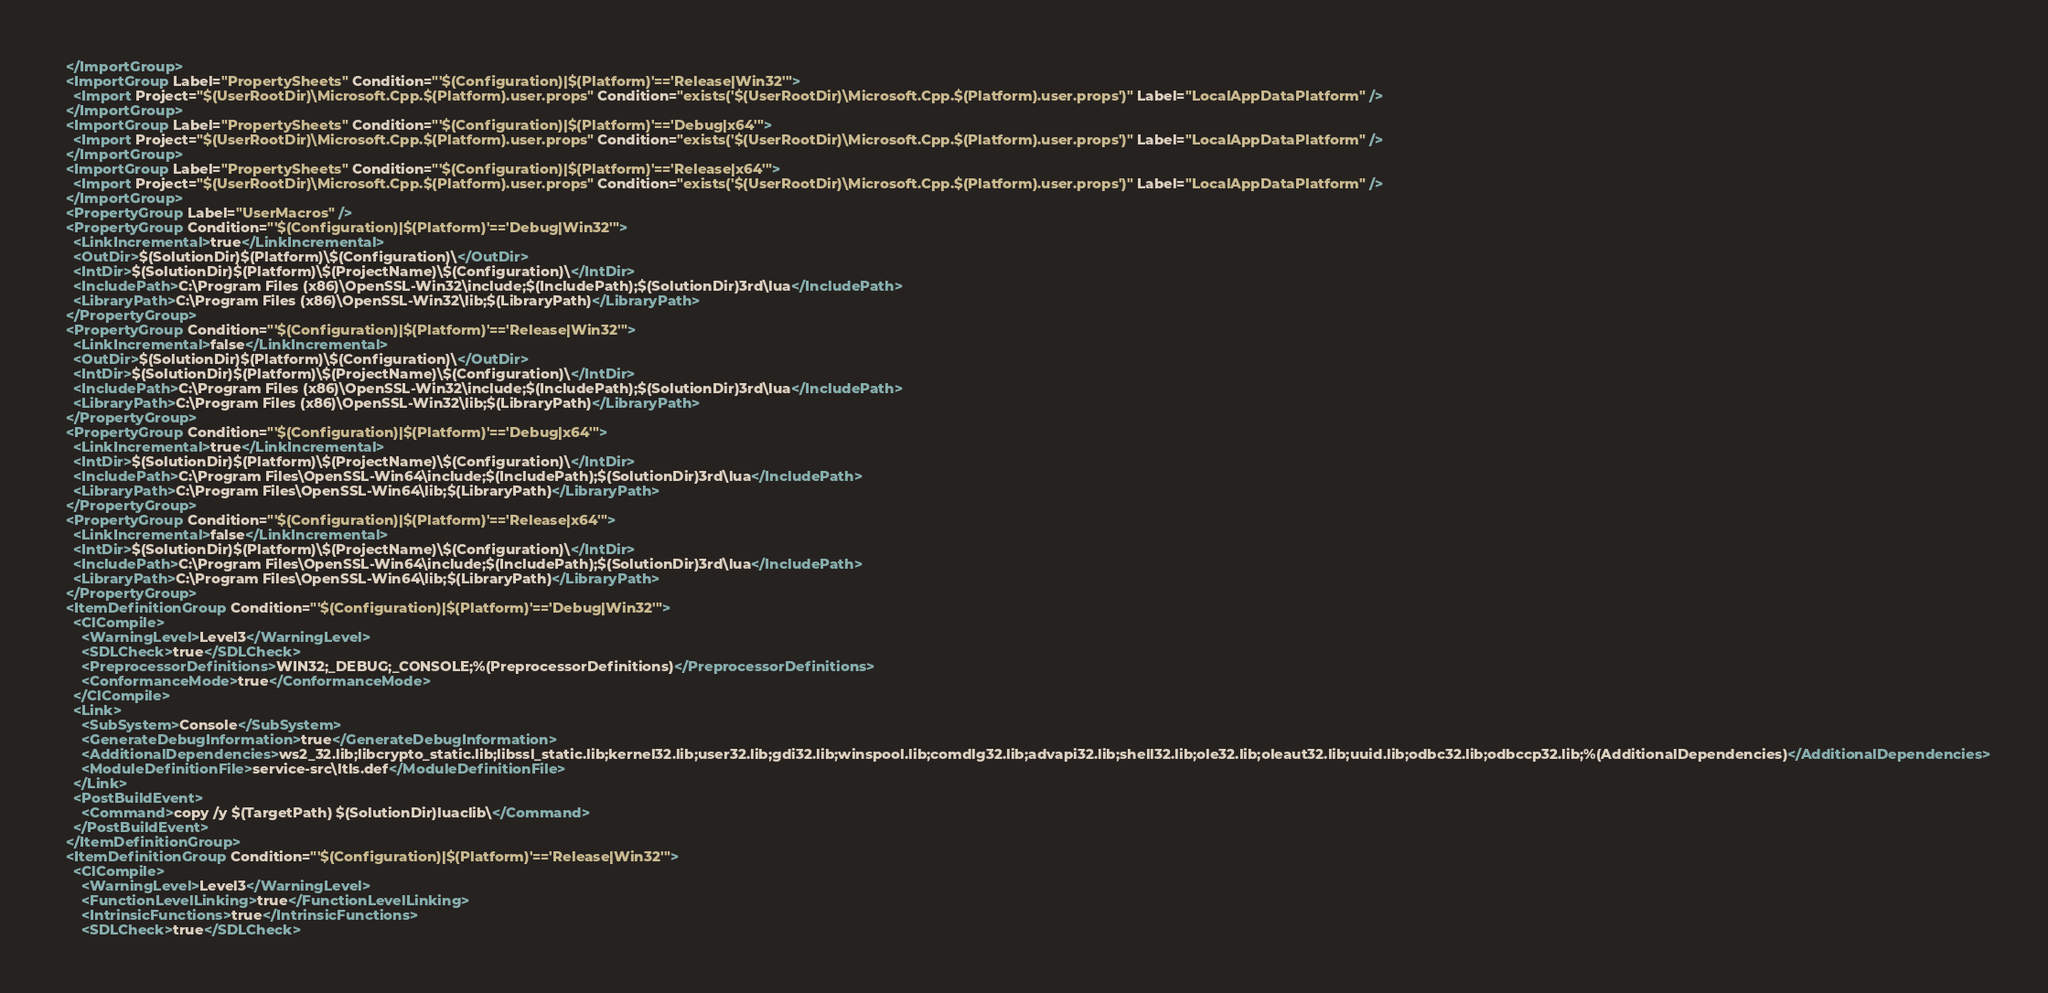Convert code to text. <code><loc_0><loc_0><loc_500><loc_500><_XML_>  </ImportGroup>
  <ImportGroup Label="PropertySheets" Condition="'$(Configuration)|$(Platform)'=='Release|Win32'">
    <Import Project="$(UserRootDir)\Microsoft.Cpp.$(Platform).user.props" Condition="exists('$(UserRootDir)\Microsoft.Cpp.$(Platform).user.props')" Label="LocalAppDataPlatform" />
  </ImportGroup>
  <ImportGroup Label="PropertySheets" Condition="'$(Configuration)|$(Platform)'=='Debug|x64'">
    <Import Project="$(UserRootDir)\Microsoft.Cpp.$(Platform).user.props" Condition="exists('$(UserRootDir)\Microsoft.Cpp.$(Platform).user.props')" Label="LocalAppDataPlatform" />
  </ImportGroup>
  <ImportGroup Label="PropertySheets" Condition="'$(Configuration)|$(Platform)'=='Release|x64'">
    <Import Project="$(UserRootDir)\Microsoft.Cpp.$(Platform).user.props" Condition="exists('$(UserRootDir)\Microsoft.Cpp.$(Platform).user.props')" Label="LocalAppDataPlatform" />
  </ImportGroup>
  <PropertyGroup Label="UserMacros" />
  <PropertyGroup Condition="'$(Configuration)|$(Platform)'=='Debug|Win32'">
    <LinkIncremental>true</LinkIncremental>
    <OutDir>$(SolutionDir)$(Platform)\$(Configuration)\</OutDir>
    <IntDir>$(SolutionDir)$(Platform)\$(ProjectName)\$(Configuration)\</IntDir>
    <IncludePath>C:\Program Files (x86)\OpenSSL-Win32\include;$(IncludePath);$(SolutionDir)3rd\lua</IncludePath>
    <LibraryPath>C:\Program Files (x86)\OpenSSL-Win32\lib;$(LibraryPath)</LibraryPath>
  </PropertyGroup>
  <PropertyGroup Condition="'$(Configuration)|$(Platform)'=='Release|Win32'">
    <LinkIncremental>false</LinkIncremental>
    <OutDir>$(SolutionDir)$(Platform)\$(Configuration)\</OutDir>
    <IntDir>$(SolutionDir)$(Platform)\$(ProjectName)\$(Configuration)\</IntDir>
    <IncludePath>C:\Program Files (x86)\OpenSSL-Win32\include;$(IncludePath);$(SolutionDir)3rd\lua</IncludePath>
    <LibraryPath>C:\Program Files (x86)\OpenSSL-Win32\lib;$(LibraryPath)</LibraryPath>
  </PropertyGroup>
  <PropertyGroup Condition="'$(Configuration)|$(Platform)'=='Debug|x64'">
    <LinkIncremental>true</LinkIncremental>
    <IntDir>$(SolutionDir)$(Platform)\$(ProjectName)\$(Configuration)\</IntDir>
    <IncludePath>C:\Program Files\OpenSSL-Win64\include;$(IncludePath);$(SolutionDir)3rd\lua</IncludePath>
    <LibraryPath>C:\Program Files\OpenSSL-Win64\lib;$(LibraryPath)</LibraryPath>
  </PropertyGroup>
  <PropertyGroup Condition="'$(Configuration)|$(Platform)'=='Release|x64'">
    <LinkIncremental>false</LinkIncremental>
    <IntDir>$(SolutionDir)$(Platform)\$(ProjectName)\$(Configuration)\</IntDir>
    <IncludePath>C:\Program Files\OpenSSL-Win64\include;$(IncludePath);$(SolutionDir)3rd\lua</IncludePath>
    <LibraryPath>C:\Program Files\OpenSSL-Win64\lib;$(LibraryPath)</LibraryPath>
  </PropertyGroup>
  <ItemDefinitionGroup Condition="'$(Configuration)|$(Platform)'=='Debug|Win32'">
    <ClCompile>
      <WarningLevel>Level3</WarningLevel>
      <SDLCheck>true</SDLCheck>
      <PreprocessorDefinitions>WIN32;_DEBUG;_CONSOLE;%(PreprocessorDefinitions)</PreprocessorDefinitions>
      <ConformanceMode>true</ConformanceMode>
    </ClCompile>
    <Link>
      <SubSystem>Console</SubSystem>
      <GenerateDebugInformation>true</GenerateDebugInformation>
      <AdditionalDependencies>ws2_32.lib;libcrypto_static.lib;libssl_static.lib;kernel32.lib;user32.lib;gdi32.lib;winspool.lib;comdlg32.lib;advapi32.lib;shell32.lib;ole32.lib;oleaut32.lib;uuid.lib;odbc32.lib;odbccp32.lib;%(AdditionalDependencies)</AdditionalDependencies>
      <ModuleDefinitionFile>service-src\ltls.def</ModuleDefinitionFile>
    </Link>
    <PostBuildEvent>
      <Command>copy /y $(TargetPath) $(SolutionDir)luaclib\</Command>
    </PostBuildEvent>
  </ItemDefinitionGroup>
  <ItemDefinitionGroup Condition="'$(Configuration)|$(Platform)'=='Release|Win32'">
    <ClCompile>
      <WarningLevel>Level3</WarningLevel>
      <FunctionLevelLinking>true</FunctionLevelLinking>
      <IntrinsicFunctions>true</IntrinsicFunctions>
      <SDLCheck>true</SDLCheck></code> 